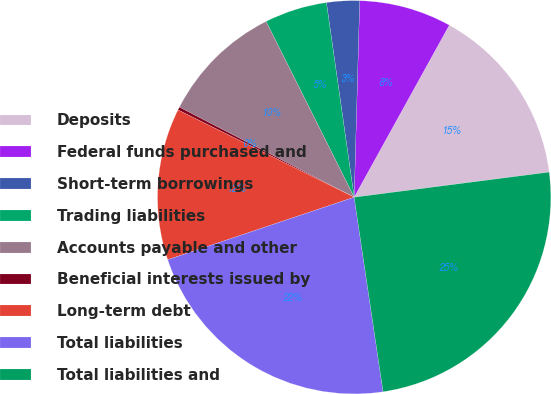Convert chart to OTSL. <chart><loc_0><loc_0><loc_500><loc_500><pie_chart><fcel>Deposits<fcel>Federal funds purchased and<fcel>Short-term borrowings<fcel>Trading liabilities<fcel>Accounts payable and other<fcel>Beneficial interests issued by<fcel>Long-term debt<fcel>Total liabilities<fcel>Total liabilities and<nl><fcel>14.92%<fcel>7.59%<fcel>2.7%<fcel>5.14%<fcel>10.03%<fcel>0.25%<fcel>12.47%<fcel>22.2%<fcel>24.69%<nl></chart> 